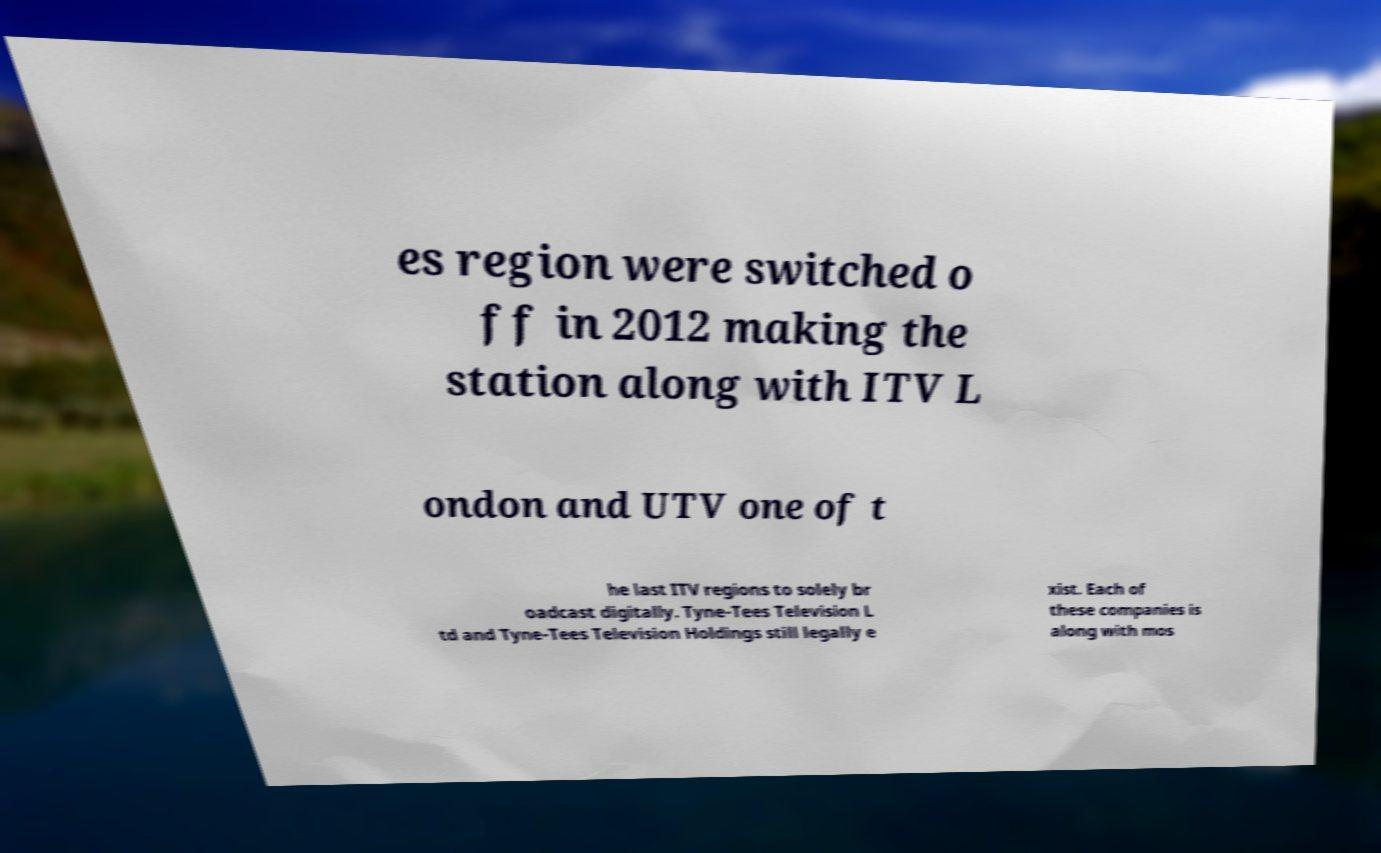Could you assist in decoding the text presented in this image and type it out clearly? es region were switched o ff in 2012 making the station along with ITV L ondon and UTV one of t he last ITV regions to solely br oadcast digitally. Tyne-Tees Television L td and Tyne-Tees Television Holdings still legally e xist. Each of these companies is along with mos 